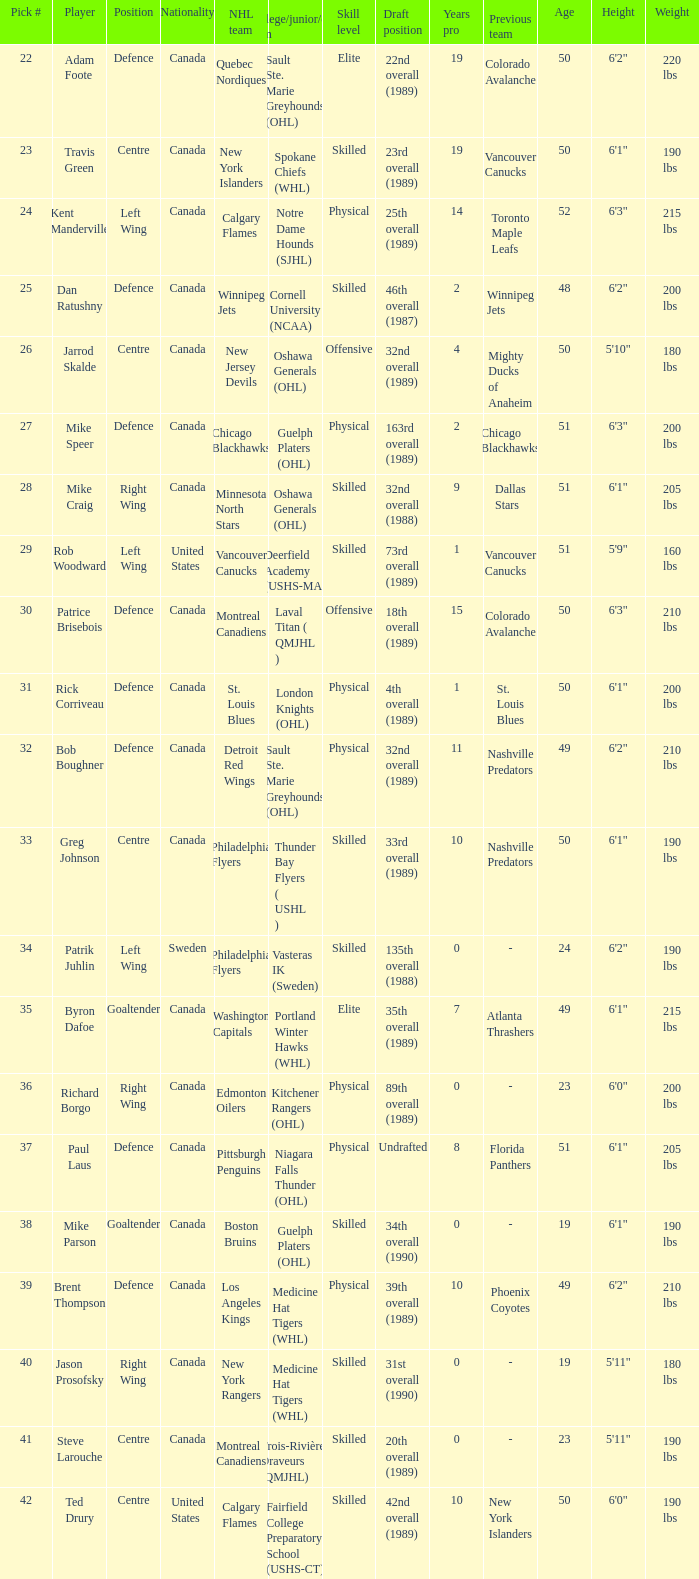How many draft picks is player byron dafoe? 1.0. 